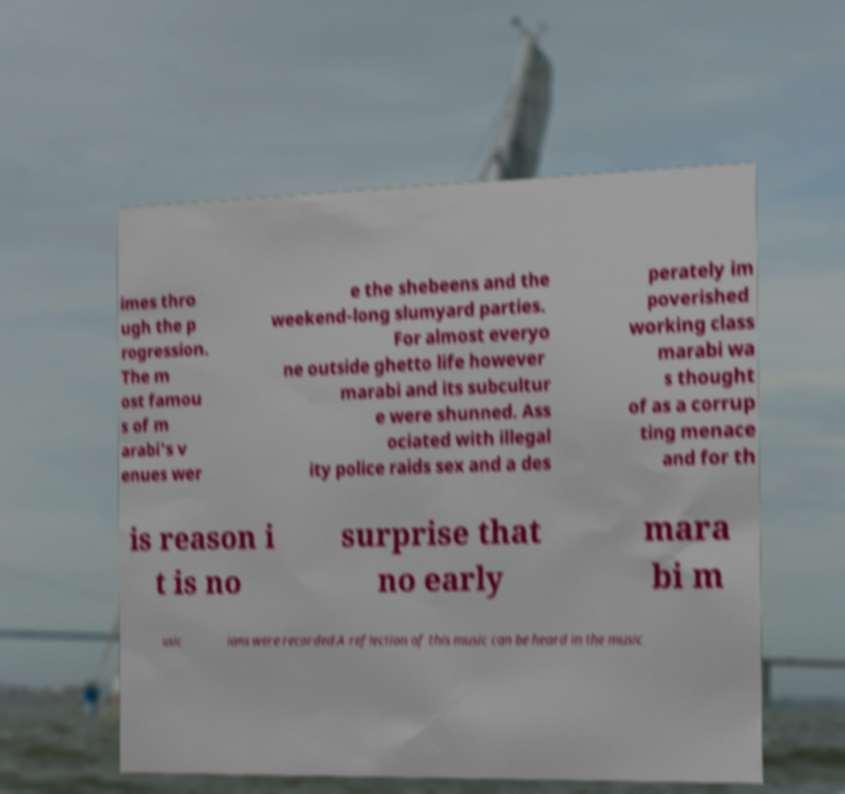Could you extract and type out the text from this image? imes thro ugh the p rogression. The m ost famou s of m arabi's v enues wer e the shebeens and the weekend-long slumyard parties. For almost everyo ne outside ghetto life however marabi and its subcultur e were shunned. Ass ociated with illegal ity police raids sex and a des perately im poverished working class marabi wa s thought of as a corrup ting menace and for th is reason i t is no surprise that no early mara bi m usic ians were recorded.A reflection of this music can be heard in the music 